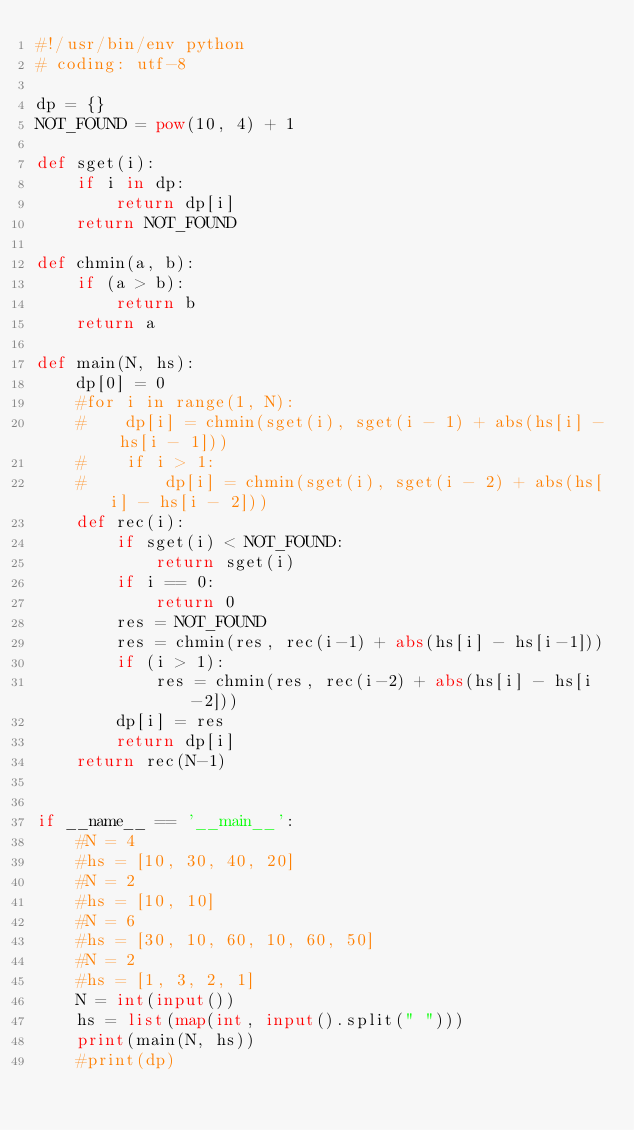Convert code to text. <code><loc_0><loc_0><loc_500><loc_500><_Python_>#!/usr/bin/env python
# coding: utf-8

dp = {}
NOT_FOUND = pow(10, 4) + 1

def sget(i):
    if i in dp:
        return dp[i]
    return NOT_FOUND

def chmin(a, b):
    if (a > b):
        return b
    return a

def main(N, hs):
    dp[0] = 0
    #for i in range(1, N):
    #    dp[i] = chmin(sget(i), sget(i - 1) + abs(hs[i] - hs[i - 1]))
    #    if i > 1:
    #        dp[i] = chmin(sget(i), sget(i - 2) + abs(hs[i] - hs[i - 2]))
    def rec(i):
        if sget(i) < NOT_FOUND:
            return sget(i)
        if i == 0:
            return 0
        res = NOT_FOUND
        res = chmin(res, rec(i-1) + abs(hs[i] - hs[i-1]))
        if (i > 1):
            res = chmin(res, rec(i-2) + abs(hs[i] - hs[i-2]))
        dp[i] = res
        return dp[i]
    return rec(N-1)


if __name__ == '__main__':
    #N = 4
    #hs = [10, 30, 40, 20]
    #N = 2
    #hs = [10, 10]
    #N = 6
    #hs = [30, 10, 60, 10, 60, 50]
    #N = 2
    #hs = [1, 3, 2, 1]
    N = int(input())
    hs = list(map(int, input().split(" ")))
    print(main(N, hs))
    #print(dp)
</code> 